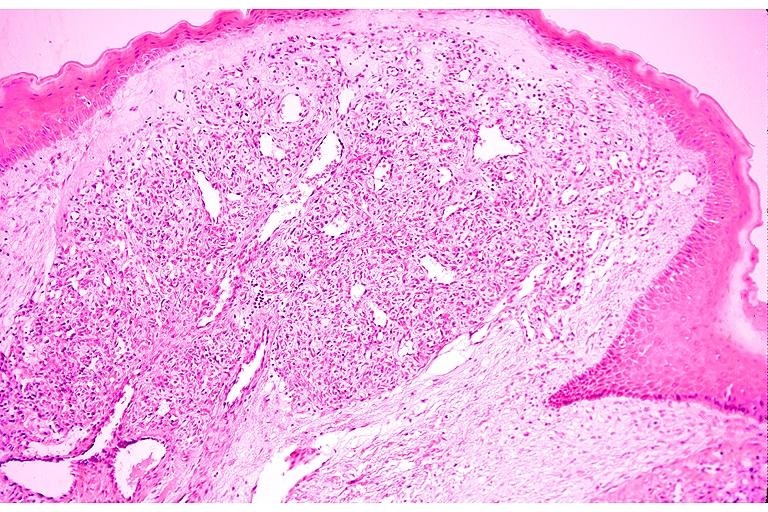does this image show capillary hemangioma?
Answer the question using a single word or phrase. Yes 